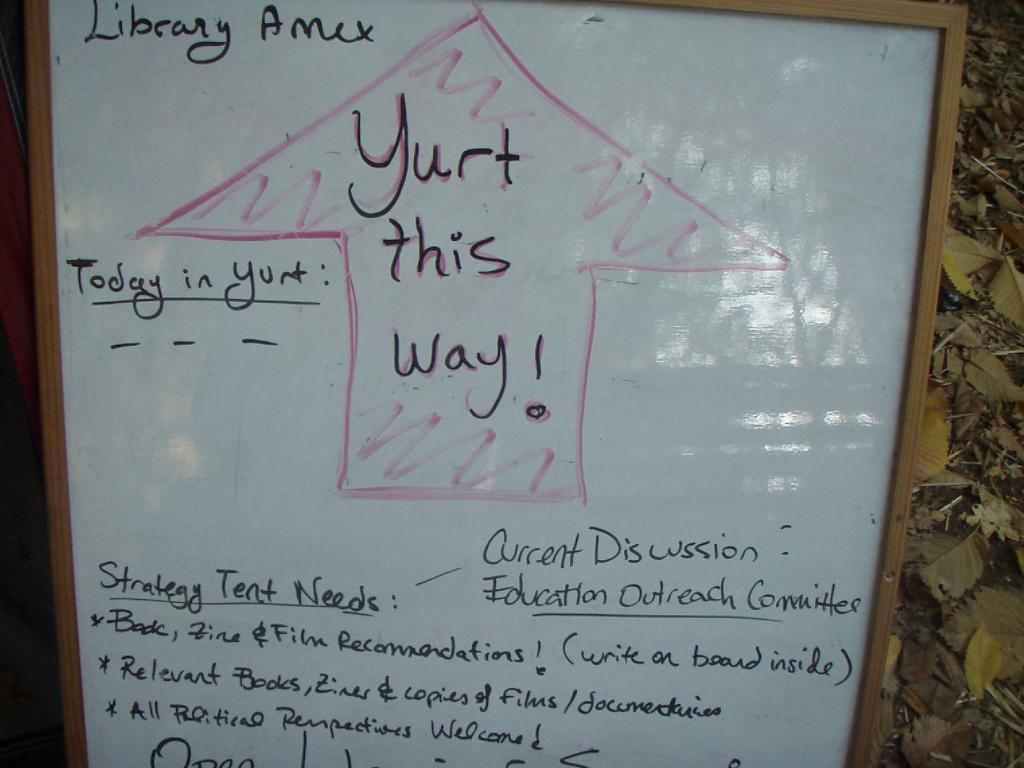<image>
Write a terse but informative summary of the picture. The dry erase board has a lot of writing on it along with an arrow pointing up with the words, "Yurt this way!" 